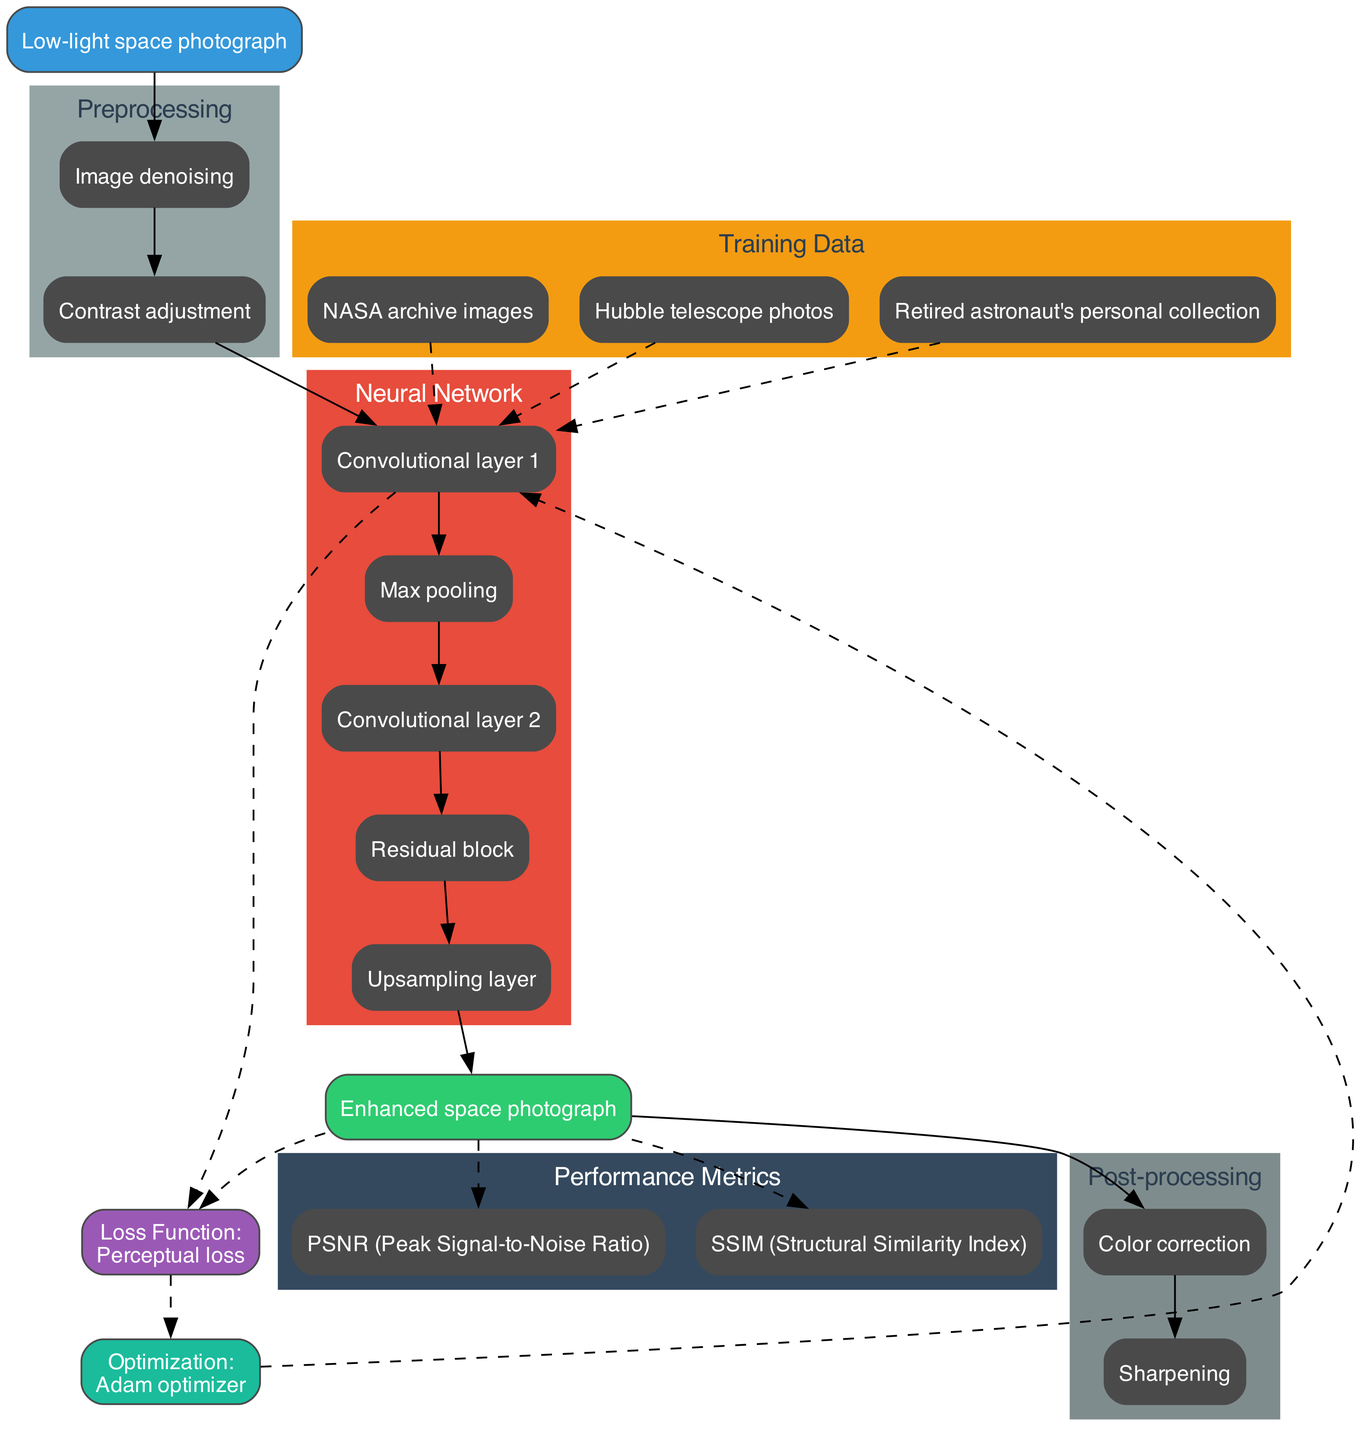What is the input to the neural network? The diagram clearly identifies the input node as "Low-light space photograph." This is the initial data that the network processes.
Answer: Low-light space photograph How many convolutional layers are there in the neural network? By examining the "Neural Network" section of the diagram, I can see that there are a total of 2 convolutional layers listed.
Answer: 2 What is the loss function used in this architecture? The diagram explicitly states "Loss Function: Perceptual loss" near the loss function node, indicating that this is the criterion used to evaluate the model's performance.
Answer: Perceptual loss Which layer follows the first convolutional layer? The diagram shows a connection from "Convolutional layer 1" to "Max pooling," indicating that max pooling is the next layer in the sequence after the first convolutional layer.
Answer: Max pooling What type of images is included in the training data? The "Training Data" section lists "NASA archive images," "Hubble telescope photos," and "Retired astronaut's personal collection," showing the sources of data used to train the neural network.
Answer: NASA archive images, Hubble telescope photos, Retired astronaut's personal collection How is the output of the neural network processed after it is generated? The "Post-processing" section shows two steps: "Color correction" and "Sharpening." These processes are applied to the output "Enhanced space photograph" to improve image quality.
Answer: Color correction, Sharpening What are the performance metrics used to evaluate the model? In the "Performance Metrics" portion of the diagram, "PSNR (Peak Signal-to-Noise Ratio)" and "SSIM (Structural Similarity Index)" are listed as the criteria for measuring the quality of the output images.
Answer: PSNR, SSIM Which optimization algorithm is utilized in this neural network? The node labeled "Optimization: Adam optimizer" indicates that the Adam optimizer is the optimization algorithm being applied during training.
Answer: Adam optimizer What step follows the layer containing the residual block? Looking at the connections in the "Neural Network" section, the "Upsampling layer" directly follows the "Residual block" layer in the architecture, indicating the next step of processing.
Answer: Upsampling layer 